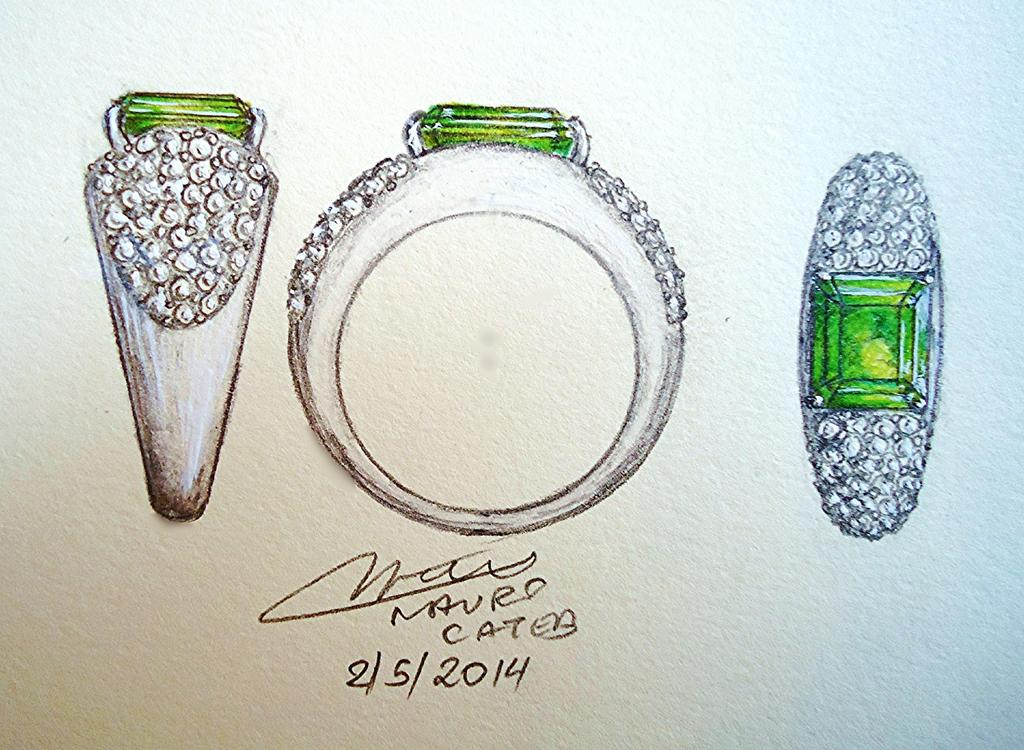What is depicted in the drawing in the image? There is a drawing of three rings with green stones in the image. What else can be seen in the image besides the drawing? There is a poster in the image. What is featured on the poster? The poster contains some text. Can you tell me how many goldfish are swimming in the drawing? There are no goldfish present in the drawing; it features three rings with green stones. What type of monkey is sitting on the poster in the image? There is no monkey present on the poster or in the image. 